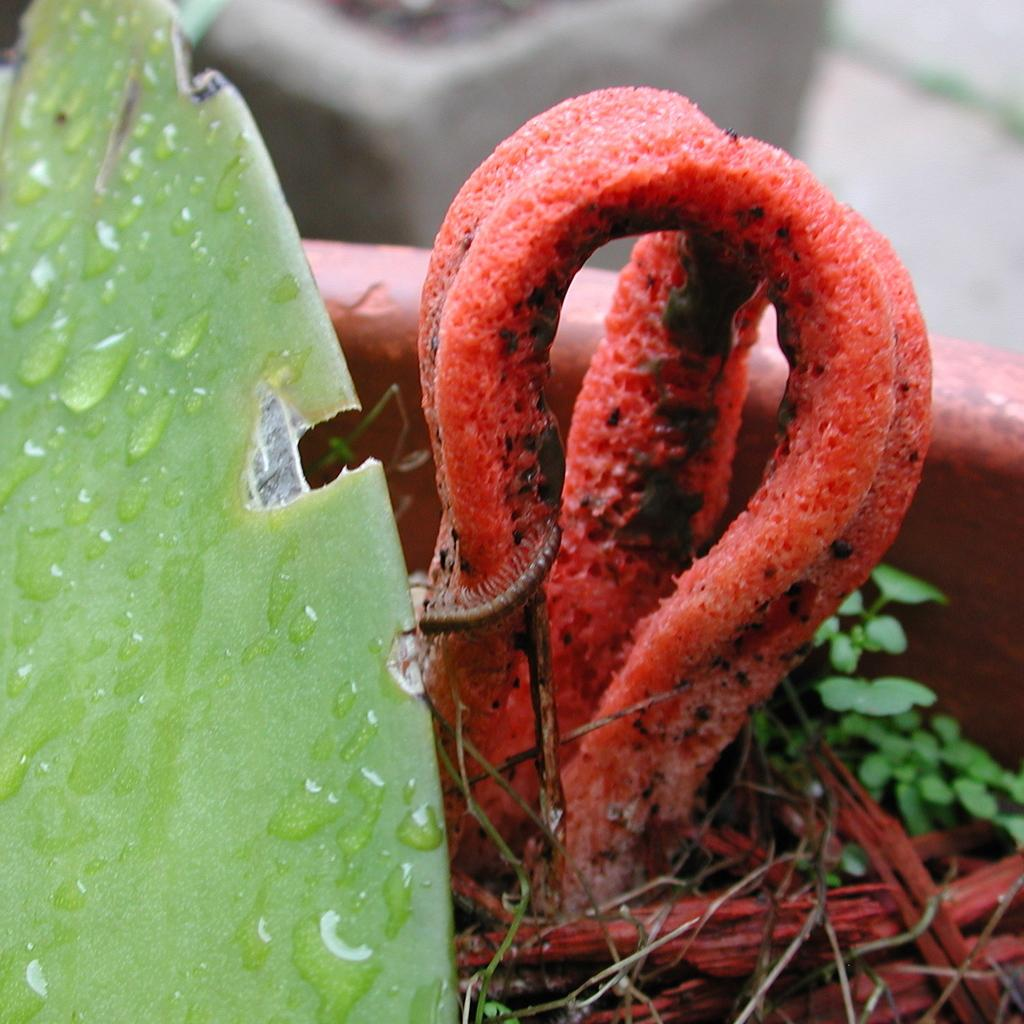What is the main subject of the image? The main subject of the image is a leaf with water droplets. Are there any other living organisms present in the image? Yes, there is a caterpillar on a plant in the image. How is the plant situated in the image? The plant is in a pot. What type of knife is being used to cut the sky in the image? There is no knife or sky present in the image; it features a leaf with water droplets and a caterpillar on a plant in a pot. 